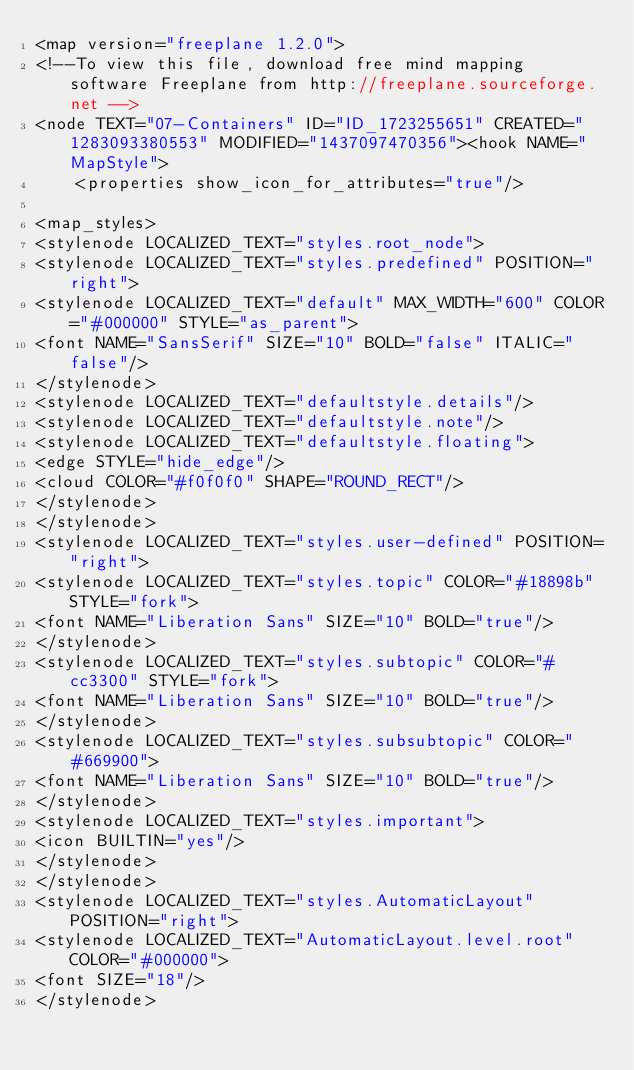<code> <loc_0><loc_0><loc_500><loc_500><_ObjectiveC_><map version="freeplane 1.2.0">
<!--To view this file, download free mind mapping software Freeplane from http://freeplane.sourceforge.net -->
<node TEXT="07-Containers" ID="ID_1723255651" CREATED="1283093380553" MODIFIED="1437097470356"><hook NAME="MapStyle">
    <properties show_icon_for_attributes="true"/>

<map_styles>
<stylenode LOCALIZED_TEXT="styles.root_node">
<stylenode LOCALIZED_TEXT="styles.predefined" POSITION="right">
<stylenode LOCALIZED_TEXT="default" MAX_WIDTH="600" COLOR="#000000" STYLE="as_parent">
<font NAME="SansSerif" SIZE="10" BOLD="false" ITALIC="false"/>
</stylenode>
<stylenode LOCALIZED_TEXT="defaultstyle.details"/>
<stylenode LOCALIZED_TEXT="defaultstyle.note"/>
<stylenode LOCALIZED_TEXT="defaultstyle.floating">
<edge STYLE="hide_edge"/>
<cloud COLOR="#f0f0f0" SHAPE="ROUND_RECT"/>
</stylenode>
</stylenode>
<stylenode LOCALIZED_TEXT="styles.user-defined" POSITION="right">
<stylenode LOCALIZED_TEXT="styles.topic" COLOR="#18898b" STYLE="fork">
<font NAME="Liberation Sans" SIZE="10" BOLD="true"/>
</stylenode>
<stylenode LOCALIZED_TEXT="styles.subtopic" COLOR="#cc3300" STYLE="fork">
<font NAME="Liberation Sans" SIZE="10" BOLD="true"/>
</stylenode>
<stylenode LOCALIZED_TEXT="styles.subsubtopic" COLOR="#669900">
<font NAME="Liberation Sans" SIZE="10" BOLD="true"/>
</stylenode>
<stylenode LOCALIZED_TEXT="styles.important">
<icon BUILTIN="yes"/>
</stylenode>
</stylenode>
<stylenode LOCALIZED_TEXT="styles.AutomaticLayout" POSITION="right">
<stylenode LOCALIZED_TEXT="AutomaticLayout.level.root" COLOR="#000000">
<font SIZE="18"/>
</stylenode></code> 